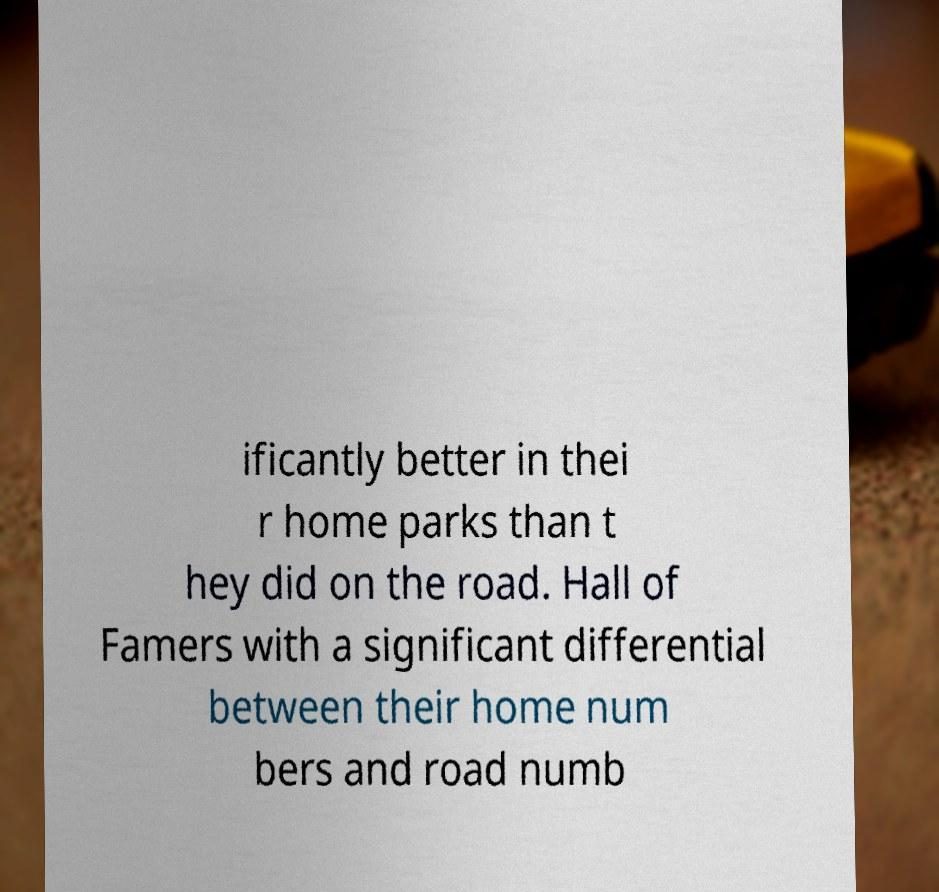Please read and relay the text visible in this image. What does it say? ificantly better in thei r home parks than t hey did on the road. Hall of Famers with a significant differential between their home num bers and road numb 